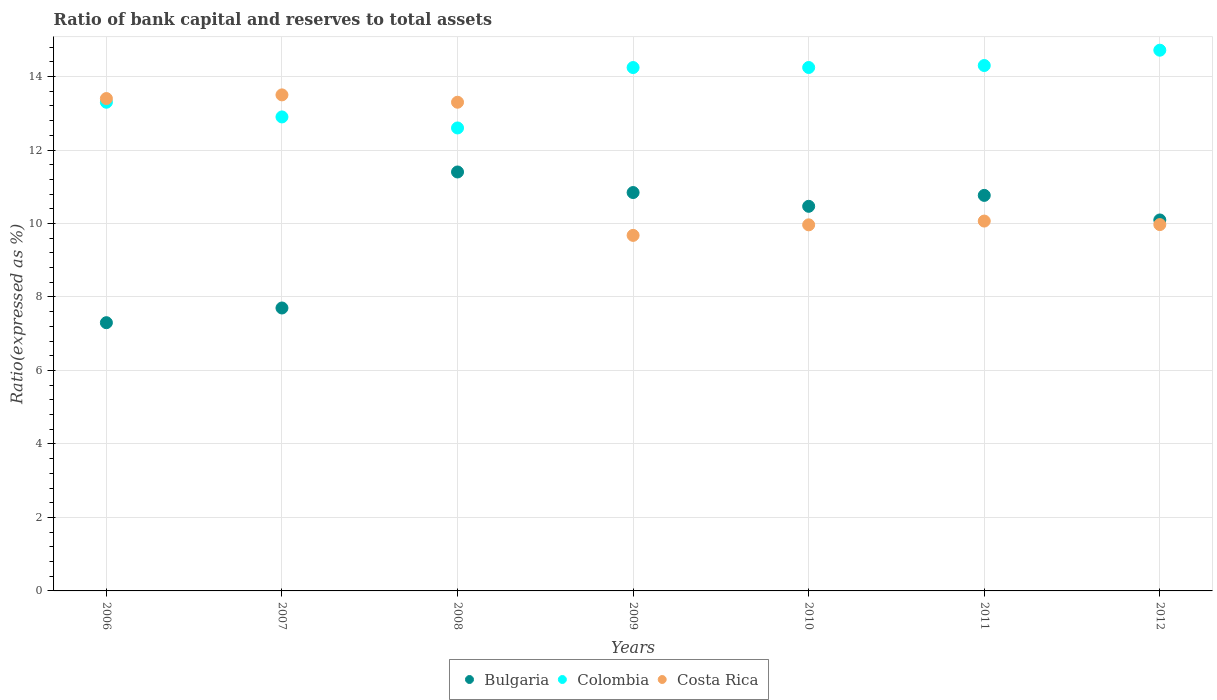How many different coloured dotlines are there?
Ensure brevity in your answer.  3. Is the number of dotlines equal to the number of legend labels?
Give a very brief answer. Yes. What is the ratio of bank capital and reserves to total assets in Bulgaria in 2006?
Your answer should be very brief. 7.3. Across all years, what is the maximum ratio of bank capital and reserves to total assets in Bulgaria?
Provide a succinct answer. 11.4. Across all years, what is the minimum ratio of bank capital and reserves to total assets in Bulgaria?
Provide a succinct answer. 7.3. In which year was the ratio of bank capital and reserves to total assets in Colombia maximum?
Your response must be concise. 2012. What is the total ratio of bank capital and reserves to total assets in Colombia in the graph?
Offer a terse response. 96.31. What is the difference between the ratio of bank capital and reserves to total assets in Colombia in 2006 and that in 2009?
Keep it short and to the point. -0.94. What is the difference between the ratio of bank capital and reserves to total assets in Bulgaria in 2011 and the ratio of bank capital and reserves to total assets in Colombia in 2009?
Offer a very short reply. -3.48. What is the average ratio of bank capital and reserves to total assets in Costa Rica per year?
Offer a terse response. 11.41. In the year 2006, what is the difference between the ratio of bank capital and reserves to total assets in Bulgaria and ratio of bank capital and reserves to total assets in Colombia?
Provide a succinct answer. -6. In how many years, is the ratio of bank capital and reserves to total assets in Bulgaria greater than 14 %?
Keep it short and to the point. 0. What is the ratio of the ratio of bank capital and reserves to total assets in Bulgaria in 2006 to that in 2009?
Provide a succinct answer. 0.67. Is the difference between the ratio of bank capital and reserves to total assets in Bulgaria in 2007 and 2009 greater than the difference between the ratio of bank capital and reserves to total assets in Colombia in 2007 and 2009?
Provide a short and direct response. No. What is the difference between the highest and the second highest ratio of bank capital and reserves to total assets in Bulgaria?
Your answer should be compact. 0.56. What is the difference between the highest and the lowest ratio of bank capital and reserves to total assets in Costa Rica?
Offer a very short reply. 3.82. In how many years, is the ratio of bank capital and reserves to total assets in Bulgaria greater than the average ratio of bank capital and reserves to total assets in Bulgaria taken over all years?
Your answer should be very brief. 5. Is the sum of the ratio of bank capital and reserves to total assets in Costa Rica in 2006 and 2008 greater than the maximum ratio of bank capital and reserves to total assets in Bulgaria across all years?
Give a very brief answer. Yes. Is it the case that in every year, the sum of the ratio of bank capital and reserves to total assets in Costa Rica and ratio of bank capital and reserves to total assets in Colombia  is greater than the ratio of bank capital and reserves to total assets in Bulgaria?
Provide a succinct answer. Yes. Does the ratio of bank capital and reserves to total assets in Bulgaria monotonically increase over the years?
Give a very brief answer. No. Is the ratio of bank capital and reserves to total assets in Colombia strictly greater than the ratio of bank capital and reserves to total assets in Costa Rica over the years?
Offer a very short reply. No. Is the ratio of bank capital and reserves to total assets in Costa Rica strictly less than the ratio of bank capital and reserves to total assets in Colombia over the years?
Keep it short and to the point. No. How many dotlines are there?
Provide a succinct answer. 3. What is the difference between two consecutive major ticks on the Y-axis?
Your answer should be very brief. 2. Are the values on the major ticks of Y-axis written in scientific E-notation?
Your answer should be compact. No. Does the graph contain any zero values?
Offer a terse response. No. Does the graph contain grids?
Provide a succinct answer. Yes. How many legend labels are there?
Give a very brief answer. 3. What is the title of the graph?
Ensure brevity in your answer.  Ratio of bank capital and reserves to total assets. Does "Slovak Republic" appear as one of the legend labels in the graph?
Your answer should be compact. No. What is the label or title of the X-axis?
Keep it short and to the point. Years. What is the label or title of the Y-axis?
Make the answer very short. Ratio(expressed as %). What is the Ratio(expressed as %) in Colombia in 2006?
Your answer should be compact. 13.3. What is the Ratio(expressed as %) in Bulgaria in 2007?
Offer a terse response. 7.7. What is the Ratio(expressed as %) in Colombia in 2007?
Provide a succinct answer. 12.9. What is the Ratio(expressed as %) in Costa Rica in 2007?
Your answer should be very brief. 13.5. What is the Ratio(expressed as %) of Bulgaria in 2008?
Provide a succinct answer. 11.4. What is the Ratio(expressed as %) in Colombia in 2008?
Give a very brief answer. 12.6. What is the Ratio(expressed as %) of Bulgaria in 2009?
Provide a short and direct response. 10.84. What is the Ratio(expressed as %) in Colombia in 2009?
Offer a terse response. 14.24. What is the Ratio(expressed as %) of Costa Rica in 2009?
Ensure brevity in your answer.  9.68. What is the Ratio(expressed as %) in Bulgaria in 2010?
Your response must be concise. 10.47. What is the Ratio(expressed as %) of Colombia in 2010?
Provide a succinct answer. 14.25. What is the Ratio(expressed as %) of Costa Rica in 2010?
Make the answer very short. 9.96. What is the Ratio(expressed as %) of Bulgaria in 2011?
Make the answer very short. 10.76. What is the Ratio(expressed as %) in Colombia in 2011?
Offer a terse response. 14.3. What is the Ratio(expressed as %) in Costa Rica in 2011?
Provide a succinct answer. 10.07. What is the Ratio(expressed as %) of Bulgaria in 2012?
Offer a very short reply. 10.1. What is the Ratio(expressed as %) in Colombia in 2012?
Ensure brevity in your answer.  14.72. What is the Ratio(expressed as %) of Costa Rica in 2012?
Provide a short and direct response. 9.97. Across all years, what is the maximum Ratio(expressed as %) of Bulgaria?
Offer a terse response. 11.4. Across all years, what is the maximum Ratio(expressed as %) of Colombia?
Your answer should be very brief. 14.72. Across all years, what is the minimum Ratio(expressed as %) of Costa Rica?
Keep it short and to the point. 9.68. What is the total Ratio(expressed as %) in Bulgaria in the graph?
Keep it short and to the point. 68.57. What is the total Ratio(expressed as %) in Colombia in the graph?
Make the answer very short. 96.31. What is the total Ratio(expressed as %) of Costa Rica in the graph?
Keep it short and to the point. 79.88. What is the difference between the Ratio(expressed as %) in Bulgaria in 2006 and that in 2007?
Provide a short and direct response. -0.4. What is the difference between the Ratio(expressed as %) in Colombia in 2006 and that in 2007?
Your response must be concise. 0.4. What is the difference between the Ratio(expressed as %) of Bulgaria in 2006 and that in 2008?
Ensure brevity in your answer.  -4.1. What is the difference between the Ratio(expressed as %) in Bulgaria in 2006 and that in 2009?
Your answer should be compact. -3.54. What is the difference between the Ratio(expressed as %) in Colombia in 2006 and that in 2009?
Provide a succinct answer. -0.94. What is the difference between the Ratio(expressed as %) of Costa Rica in 2006 and that in 2009?
Make the answer very short. 3.72. What is the difference between the Ratio(expressed as %) of Bulgaria in 2006 and that in 2010?
Your answer should be very brief. -3.17. What is the difference between the Ratio(expressed as %) in Colombia in 2006 and that in 2010?
Keep it short and to the point. -0.95. What is the difference between the Ratio(expressed as %) of Costa Rica in 2006 and that in 2010?
Your response must be concise. 3.44. What is the difference between the Ratio(expressed as %) of Bulgaria in 2006 and that in 2011?
Make the answer very short. -3.46. What is the difference between the Ratio(expressed as %) of Colombia in 2006 and that in 2011?
Provide a short and direct response. -1. What is the difference between the Ratio(expressed as %) in Costa Rica in 2006 and that in 2011?
Your answer should be very brief. 3.33. What is the difference between the Ratio(expressed as %) in Bulgaria in 2006 and that in 2012?
Keep it short and to the point. -2.8. What is the difference between the Ratio(expressed as %) in Colombia in 2006 and that in 2012?
Your response must be concise. -1.42. What is the difference between the Ratio(expressed as %) of Costa Rica in 2006 and that in 2012?
Offer a very short reply. 3.43. What is the difference between the Ratio(expressed as %) of Bulgaria in 2007 and that in 2008?
Give a very brief answer. -3.7. What is the difference between the Ratio(expressed as %) in Bulgaria in 2007 and that in 2009?
Your answer should be very brief. -3.14. What is the difference between the Ratio(expressed as %) of Colombia in 2007 and that in 2009?
Ensure brevity in your answer.  -1.34. What is the difference between the Ratio(expressed as %) of Costa Rica in 2007 and that in 2009?
Your answer should be very brief. 3.82. What is the difference between the Ratio(expressed as %) in Bulgaria in 2007 and that in 2010?
Ensure brevity in your answer.  -2.77. What is the difference between the Ratio(expressed as %) in Colombia in 2007 and that in 2010?
Give a very brief answer. -1.35. What is the difference between the Ratio(expressed as %) in Costa Rica in 2007 and that in 2010?
Provide a succinct answer. 3.54. What is the difference between the Ratio(expressed as %) of Bulgaria in 2007 and that in 2011?
Keep it short and to the point. -3.06. What is the difference between the Ratio(expressed as %) of Colombia in 2007 and that in 2011?
Offer a terse response. -1.4. What is the difference between the Ratio(expressed as %) in Costa Rica in 2007 and that in 2011?
Keep it short and to the point. 3.43. What is the difference between the Ratio(expressed as %) in Bulgaria in 2007 and that in 2012?
Give a very brief answer. -2.4. What is the difference between the Ratio(expressed as %) in Colombia in 2007 and that in 2012?
Your answer should be very brief. -1.82. What is the difference between the Ratio(expressed as %) of Costa Rica in 2007 and that in 2012?
Provide a succinct answer. 3.53. What is the difference between the Ratio(expressed as %) of Bulgaria in 2008 and that in 2009?
Your answer should be compact. 0.56. What is the difference between the Ratio(expressed as %) in Colombia in 2008 and that in 2009?
Offer a very short reply. -1.64. What is the difference between the Ratio(expressed as %) of Costa Rica in 2008 and that in 2009?
Keep it short and to the point. 3.62. What is the difference between the Ratio(expressed as %) in Bulgaria in 2008 and that in 2010?
Ensure brevity in your answer.  0.93. What is the difference between the Ratio(expressed as %) in Colombia in 2008 and that in 2010?
Ensure brevity in your answer.  -1.65. What is the difference between the Ratio(expressed as %) of Costa Rica in 2008 and that in 2010?
Provide a short and direct response. 3.34. What is the difference between the Ratio(expressed as %) in Bulgaria in 2008 and that in 2011?
Offer a terse response. 0.64. What is the difference between the Ratio(expressed as %) of Colombia in 2008 and that in 2011?
Keep it short and to the point. -1.7. What is the difference between the Ratio(expressed as %) of Costa Rica in 2008 and that in 2011?
Offer a terse response. 3.23. What is the difference between the Ratio(expressed as %) of Bulgaria in 2008 and that in 2012?
Give a very brief answer. 1.31. What is the difference between the Ratio(expressed as %) of Colombia in 2008 and that in 2012?
Your answer should be very brief. -2.12. What is the difference between the Ratio(expressed as %) in Costa Rica in 2008 and that in 2012?
Your response must be concise. 3.33. What is the difference between the Ratio(expressed as %) of Bulgaria in 2009 and that in 2010?
Make the answer very short. 0.37. What is the difference between the Ratio(expressed as %) of Colombia in 2009 and that in 2010?
Give a very brief answer. -0. What is the difference between the Ratio(expressed as %) of Costa Rica in 2009 and that in 2010?
Make the answer very short. -0.29. What is the difference between the Ratio(expressed as %) in Bulgaria in 2009 and that in 2011?
Offer a terse response. 0.08. What is the difference between the Ratio(expressed as %) in Colombia in 2009 and that in 2011?
Provide a succinct answer. -0.06. What is the difference between the Ratio(expressed as %) in Costa Rica in 2009 and that in 2011?
Ensure brevity in your answer.  -0.39. What is the difference between the Ratio(expressed as %) in Bulgaria in 2009 and that in 2012?
Ensure brevity in your answer.  0.75. What is the difference between the Ratio(expressed as %) of Colombia in 2009 and that in 2012?
Your answer should be compact. -0.47. What is the difference between the Ratio(expressed as %) in Costa Rica in 2009 and that in 2012?
Ensure brevity in your answer.  -0.29. What is the difference between the Ratio(expressed as %) in Bulgaria in 2010 and that in 2011?
Give a very brief answer. -0.3. What is the difference between the Ratio(expressed as %) of Colombia in 2010 and that in 2011?
Ensure brevity in your answer.  -0.05. What is the difference between the Ratio(expressed as %) of Costa Rica in 2010 and that in 2011?
Make the answer very short. -0.1. What is the difference between the Ratio(expressed as %) in Bulgaria in 2010 and that in 2012?
Give a very brief answer. 0.37. What is the difference between the Ratio(expressed as %) in Colombia in 2010 and that in 2012?
Your response must be concise. -0.47. What is the difference between the Ratio(expressed as %) of Costa Rica in 2010 and that in 2012?
Your answer should be compact. -0.01. What is the difference between the Ratio(expressed as %) in Bulgaria in 2011 and that in 2012?
Your response must be concise. 0.67. What is the difference between the Ratio(expressed as %) of Colombia in 2011 and that in 2012?
Offer a very short reply. -0.42. What is the difference between the Ratio(expressed as %) in Costa Rica in 2011 and that in 2012?
Your answer should be very brief. 0.1. What is the difference between the Ratio(expressed as %) in Bulgaria in 2006 and the Ratio(expressed as %) in Costa Rica in 2007?
Keep it short and to the point. -6.2. What is the difference between the Ratio(expressed as %) in Bulgaria in 2006 and the Ratio(expressed as %) in Colombia in 2008?
Ensure brevity in your answer.  -5.3. What is the difference between the Ratio(expressed as %) of Bulgaria in 2006 and the Ratio(expressed as %) of Costa Rica in 2008?
Ensure brevity in your answer.  -6. What is the difference between the Ratio(expressed as %) in Bulgaria in 2006 and the Ratio(expressed as %) in Colombia in 2009?
Your answer should be very brief. -6.94. What is the difference between the Ratio(expressed as %) of Bulgaria in 2006 and the Ratio(expressed as %) of Costa Rica in 2009?
Offer a very short reply. -2.38. What is the difference between the Ratio(expressed as %) of Colombia in 2006 and the Ratio(expressed as %) of Costa Rica in 2009?
Keep it short and to the point. 3.62. What is the difference between the Ratio(expressed as %) of Bulgaria in 2006 and the Ratio(expressed as %) of Colombia in 2010?
Your answer should be very brief. -6.95. What is the difference between the Ratio(expressed as %) of Bulgaria in 2006 and the Ratio(expressed as %) of Costa Rica in 2010?
Provide a short and direct response. -2.66. What is the difference between the Ratio(expressed as %) in Colombia in 2006 and the Ratio(expressed as %) in Costa Rica in 2010?
Keep it short and to the point. 3.34. What is the difference between the Ratio(expressed as %) in Bulgaria in 2006 and the Ratio(expressed as %) in Colombia in 2011?
Your answer should be very brief. -7. What is the difference between the Ratio(expressed as %) of Bulgaria in 2006 and the Ratio(expressed as %) of Costa Rica in 2011?
Give a very brief answer. -2.77. What is the difference between the Ratio(expressed as %) of Colombia in 2006 and the Ratio(expressed as %) of Costa Rica in 2011?
Offer a very short reply. 3.23. What is the difference between the Ratio(expressed as %) of Bulgaria in 2006 and the Ratio(expressed as %) of Colombia in 2012?
Provide a short and direct response. -7.42. What is the difference between the Ratio(expressed as %) of Bulgaria in 2006 and the Ratio(expressed as %) of Costa Rica in 2012?
Ensure brevity in your answer.  -2.67. What is the difference between the Ratio(expressed as %) in Colombia in 2006 and the Ratio(expressed as %) in Costa Rica in 2012?
Offer a very short reply. 3.33. What is the difference between the Ratio(expressed as %) in Bulgaria in 2007 and the Ratio(expressed as %) in Colombia in 2008?
Offer a terse response. -4.9. What is the difference between the Ratio(expressed as %) in Bulgaria in 2007 and the Ratio(expressed as %) in Costa Rica in 2008?
Your answer should be compact. -5.6. What is the difference between the Ratio(expressed as %) in Colombia in 2007 and the Ratio(expressed as %) in Costa Rica in 2008?
Make the answer very short. -0.4. What is the difference between the Ratio(expressed as %) in Bulgaria in 2007 and the Ratio(expressed as %) in Colombia in 2009?
Your answer should be very brief. -6.54. What is the difference between the Ratio(expressed as %) of Bulgaria in 2007 and the Ratio(expressed as %) of Costa Rica in 2009?
Your response must be concise. -1.98. What is the difference between the Ratio(expressed as %) in Colombia in 2007 and the Ratio(expressed as %) in Costa Rica in 2009?
Keep it short and to the point. 3.22. What is the difference between the Ratio(expressed as %) of Bulgaria in 2007 and the Ratio(expressed as %) of Colombia in 2010?
Provide a succinct answer. -6.55. What is the difference between the Ratio(expressed as %) of Bulgaria in 2007 and the Ratio(expressed as %) of Costa Rica in 2010?
Your answer should be very brief. -2.26. What is the difference between the Ratio(expressed as %) in Colombia in 2007 and the Ratio(expressed as %) in Costa Rica in 2010?
Your response must be concise. 2.94. What is the difference between the Ratio(expressed as %) of Bulgaria in 2007 and the Ratio(expressed as %) of Colombia in 2011?
Your response must be concise. -6.6. What is the difference between the Ratio(expressed as %) in Bulgaria in 2007 and the Ratio(expressed as %) in Costa Rica in 2011?
Offer a very short reply. -2.37. What is the difference between the Ratio(expressed as %) in Colombia in 2007 and the Ratio(expressed as %) in Costa Rica in 2011?
Your answer should be compact. 2.83. What is the difference between the Ratio(expressed as %) in Bulgaria in 2007 and the Ratio(expressed as %) in Colombia in 2012?
Make the answer very short. -7.02. What is the difference between the Ratio(expressed as %) in Bulgaria in 2007 and the Ratio(expressed as %) in Costa Rica in 2012?
Offer a terse response. -2.27. What is the difference between the Ratio(expressed as %) of Colombia in 2007 and the Ratio(expressed as %) of Costa Rica in 2012?
Offer a terse response. 2.93. What is the difference between the Ratio(expressed as %) of Bulgaria in 2008 and the Ratio(expressed as %) of Colombia in 2009?
Your answer should be compact. -2.84. What is the difference between the Ratio(expressed as %) in Bulgaria in 2008 and the Ratio(expressed as %) in Costa Rica in 2009?
Your answer should be compact. 1.73. What is the difference between the Ratio(expressed as %) in Colombia in 2008 and the Ratio(expressed as %) in Costa Rica in 2009?
Your response must be concise. 2.92. What is the difference between the Ratio(expressed as %) in Bulgaria in 2008 and the Ratio(expressed as %) in Colombia in 2010?
Offer a very short reply. -2.84. What is the difference between the Ratio(expressed as %) in Bulgaria in 2008 and the Ratio(expressed as %) in Costa Rica in 2010?
Make the answer very short. 1.44. What is the difference between the Ratio(expressed as %) of Colombia in 2008 and the Ratio(expressed as %) of Costa Rica in 2010?
Give a very brief answer. 2.64. What is the difference between the Ratio(expressed as %) in Bulgaria in 2008 and the Ratio(expressed as %) in Colombia in 2011?
Make the answer very short. -2.9. What is the difference between the Ratio(expressed as %) of Bulgaria in 2008 and the Ratio(expressed as %) of Costa Rica in 2011?
Provide a succinct answer. 1.34. What is the difference between the Ratio(expressed as %) of Colombia in 2008 and the Ratio(expressed as %) of Costa Rica in 2011?
Your answer should be very brief. 2.53. What is the difference between the Ratio(expressed as %) of Bulgaria in 2008 and the Ratio(expressed as %) of Colombia in 2012?
Offer a terse response. -3.31. What is the difference between the Ratio(expressed as %) of Bulgaria in 2008 and the Ratio(expressed as %) of Costa Rica in 2012?
Make the answer very short. 1.43. What is the difference between the Ratio(expressed as %) of Colombia in 2008 and the Ratio(expressed as %) of Costa Rica in 2012?
Offer a very short reply. 2.63. What is the difference between the Ratio(expressed as %) in Bulgaria in 2009 and the Ratio(expressed as %) in Colombia in 2010?
Offer a terse response. -3.4. What is the difference between the Ratio(expressed as %) in Bulgaria in 2009 and the Ratio(expressed as %) in Costa Rica in 2010?
Provide a succinct answer. 0.88. What is the difference between the Ratio(expressed as %) of Colombia in 2009 and the Ratio(expressed as %) of Costa Rica in 2010?
Offer a terse response. 4.28. What is the difference between the Ratio(expressed as %) of Bulgaria in 2009 and the Ratio(expressed as %) of Colombia in 2011?
Make the answer very short. -3.46. What is the difference between the Ratio(expressed as %) of Bulgaria in 2009 and the Ratio(expressed as %) of Costa Rica in 2011?
Offer a terse response. 0.78. What is the difference between the Ratio(expressed as %) in Colombia in 2009 and the Ratio(expressed as %) in Costa Rica in 2011?
Offer a very short reply. 4.18. What is the difference between the Ratio(expressed as %) of Bulgaria in 2009 and the Ratio(expressed as %) of Colombia in 2012?
Your answer should be very brief. -3.87. What is the difference between the Ratio(expressed as %) in Bulgaria in 2009 and the Ratio(expressed as %) in Costa Rica in 2012?
Provide a succinct answer. 0.87. What is the difference between the Ratio(expressed as %) of Colombia in 2009 and the Ratio(expressed as %) of Costa Rica in 2012?
Offer a terse response. 4.27. What is the difference between the Ratio(expressed as %) in Bulgaria in 2010 and the Ratio(expressed as %) in Colombia in 2011?
Your answer should be very brief. -3.83. What is the difference between the Ratio(expressed as %) of Bulgaria in 2010 and the Ratio(expressed as %) of Costa Rica in 2011?
Your answer should be compact. 0.4. What is the difference between the Ratio(expressed as %) in Colombia in 2010 and the Ratio(expressed as %) in Costa Rica in 2011?
Your answer should be compact. 4.18. What is the difference between the Ratio(expressed as %) in Bulgaria in 2010 and the Ratio(expressed as %) in Colombia in 2012?
Your response must be concise. -4.25. What is the difference between the Ratio(expressed as %) of Bulgaria in 2010 and the Ratio(expressed as %) of Costa Rica in 2012?
Ensure brevity in your answer.  0.5. What is the difference between the Ratio(expressed as %) in Colombia in 2010 and the Ratio(expressed as %) in Costa Rica in 2012?
Your answer should be compact. 4.28. What is the difference between the Ratio(expressed as %) of Bulgaria in 2011 and the Ratio(expressed as %) of Colombia in 2012?
Ensure brevity in your answer.  -3.95. What is the difference between the Ratio(expressed as %) in Bulgaria in 2011 and the Ratio(expressed as %) in Costa Rica in 2012?
Your answer should be very brief. 0.79. What is the difference between the Ratio(expressed as %) of Colombia in 2011 and the Ratio(expressed as %) of Costa Rica in 2012?
Your answer should be very brief. 4.33. What is the average Ratio(expressed as %) of Bulgaria per year?
Offer a terse response. 9.8. What is the average Ratio(expressed as %) of Colombia per year?
Offer a very short reply. 13.76. What is the average Ratio(expressed as %) of Costa Rica per year?
Keep it short and to the point. 11.41. In the year 2006, what is the difference between the Ratio(expressed as %) of Bulgaria and Ratio(expressed as %) of Colombia?
Make the answer very short. -6. In the year 2007, what is the difference between the Ratio(expressed as %) in Colombia and Ratio(expressed as %) in Costa Rica?
Keep it short and to the point. -0.6. In the year 2008, what is the difference between the Ratio(expressed as %) of Bulgaria and Ratio(expressed as %) of Colombia?
Your answer should be very brief. -1.2. In the year 2008, what is the difference between the Ratio(expressed as %) of Bulgaria and Ratio(expressed as %) of Costa Rica?
Offer a terse response. -1.9. In the year 2008, what is the difference between the Ratio(expressed as %) in Colombia and Ratio(expressed as %) in Costa Rica?
Provide a succinct answer. -0.7. In the year 2009, what is the difference between the Ratio(expressed as %) in Bulgaria and Ratio(expressed as %) in Colombia?
Your answer should be very brief. -3.4. In the year 2009, what is the difference between the Ratio(expressed as %) in Bulgaria and Ratio(expressed as %) in Costa Rica?
Ensure brevity in your answer.  1.17. In the year 2009, what is the difference between the Ratio(expressed as %) in Colombia and Ratio(expressed as %) in Costa Rica?
Keep it short and to the point. 4.57. In the year 2010, what is the difference between the Ratio(expressed as %) of Bulgaria and Ratio(expressed as %) of Colombia?
Your answer should be very brief. -3.78. In the year 2010, what is the difference between the Ratio(expressed as %) of Bulgaria and Ratio(expressed as %) of Costa Rica?
Your answer should be compact. 0.5. In the year 2010, what is the difference between the Ratio(expressed as %) of Colombia and Ratio(expressed as %) of Costa Rica?
Offer a very short reply. 4.28. In the year 2011, what is the difference between the Ratio(expressed as %) in Bulgaria and Ratio(expressed as %) in Colombia?
Provide a short and direct response. -3.53. In the year 2011, what is the difference between the Ratio(expressed as %) in Bulgaria and Ratio(expressed as %) in Costa Rica?
Keep it short and to the point. 0.7. In the year 2011, what is the difference between the Ratio(expressed as %) of Colombia and Ratio(expressed as %) of Costa Rica?
Your answer should be very brief. 4.23. In the year 2012, what is the difference between the Ratio(expressed as %) in Bulgaria and Ratio(expressed as %) in Colombia?
Your answer should be compact. -4.62. In the year 2012, what is the difference between the Ratio(expressed as %) of Bulgaria and Ratio(expressed as %) of Costa Rica?
Keep it short and to the point. 0.13. In the year 2012, what is the difference between the Ratio(expressed as %) in Colombia and Ratio(expressed as %) in Costa Rica?
Make the answer very short. 4.75. What is the ratio of the Ratio(expressed as %) in Bulgaria in 2006 to that in 2007?
Your answer should be very brief. 0.95. What is the ratio of the Ratio(expressed as %) in Colombia in 2006 to that in 2007?
Ensure brevity in your answer.  1.03. What is the ratio of the Ratio(expressed as %) of Costa Rica in 2006 to that in 2007?
Your answer should be very brief. 0.99. What is the ratio of the Ratio(expressed as %) in Bulgaria in 2006 to that in 2008?
Provide a succinct answer. 0.64. What is the ratio of the Ratio(expressed as %) in Colombia in 2006 to that in 2008?
Give a very brief answer. 1.06. What is the ratio of the Ratio(expressed as %) of Costa Rica in 2006 to that in 2008?
Provide a short and direct response. 1.01. What is the ratio of the Ratio(expressed as %) in Bulgaria in 2006 to that in 2009?
Give a very brief answer. 0.67. What is the ratio of the Ratio(expressed as %) of Colombia in 2006 to that in 2009?
Ensure brevity in your answer.  0.93. What is the ratio of the Ratio(expressed as %) in Costa Rica in 2006 to that in 2009?
Ensure brevity in your answer.  1.38. What is the ratio of the Ratio(expressed as %) in Bulgaria in 2006 to that in 2010?
Provide a short and direct response. 0.7. What is the ratio of the Ratio(expressed as %) in Colombia in 2006 to that in 2010?
Ensure brevity in your answer.  0.93. What is the ratio of the Ratio(expressed as %) in Costa Rica in 2006 to that in 2010?
Provide a short and direct response. 1.34. What is the ratio of the Ratio(expressed as %) in Bulgaria in 2006 to that in 2011?
Offer a very short reply. 0.68. What is the ratio of the Ratio(expressed as %) in Colombia in 2006 to that in 2011?
Your response must be concise. 0.93. What is the ratio of the Ratio(expressed as %) of Costa Rica in 2006 to that in 2011?
Ensure brevity in your answer.  1.33. What is the ratio of the Ratio(expressed as %) in Bulgaria in 2006 to that in 2012?
Make the answer very short. 0.72. What is the ratio of the Ratio(expressed as %) in Colombia in 2006 to that in 2012?
Keep it short and to the point. 0.9. What is the ratio of the Ratio(expressed as %) in Costa Rica in 2006 to that in 2012?
Ensure brevity in your answer.  1.34. What is the ratio of the Ratio(expressed as %) of Bulgaria in 2007 to that in 2008?
Your response must be concise. 0.68. What is the ratio of the Ratio(expressed as %) of Colombia in 2007 to that in 2008?
Your answer should be very brief. 1.02. What is the ratio of the Ratio(expressed as %) of Costa Rica in 2007 to that in 2008?
Keep it short and to the point. 1.01. What is the ratio of the Ratio(expressed as %) of Bulgaria in 2007 to that in 2009?
Your answer should be very brief. 0.71. What is the ratio of the Ratio(expressed as %) of Colombia in 2007 to that in 2009?
Your response must be concise. 0.91. What is the ratio of the Ratio(expressed as %) of Costa Rica in 2007 to that in 2009?
Offer a terse response. 1.4. What is the ratio of the Ratio(expressed as %) of Bulgaria in 2007 to that in 2010?
Offer a very short reply. 0.74. What is the ratio of the Ratio(expressed as %) of Colombia in 2007 to that in 2010?
Your answer should be very brief. 0.91. What is the ratio of the Ratio(expressed as %) in Costa Rica in 2007 to that in 2010?
Offer a very short reply. 1.35. What is the ratio of the Ratio(expressed as %) of Bulgaria in 2007 to that in 2011?
Ensure brevity in your answer.  0.72. What is the ratio of the Ratio(expressed as %) of Colombia in 2007 to that in 2011?
Your response must be concise. 0.9. What is the ratio of the Ratio(expressed as %) of Costa Rica in 2007 to that in 2011?
Your answer should be very brief. 1.34. What is the ratio of the Ratio(expressed as %) in Bulgaria in 2007 to that in 2012?
Offer a terse response. 0.76. What is the ratio of the Ratio(expressed as %) in Colombia in 2007 to that in 2012?
Keep it short and to the point. 0.88. What is the ratio of the Ratio(expressed as %) of Costa Rica in 2007 to that in 2012?
Give a very brief answer. 1.35. What is the ratio of the Ratio(expressed as %) in Bulgaria in 2008 to that in 2009?
Your response must be concise. 1.05. What is the ratio of the Ratio(expressed as %) of Colombia in 2008 to that in 2009?
Keep it short and to the point. 0.88. What is the ratio of the Ratio(expressed as %) of Costa Rica in 2008 to that in 2009?
Offer a terse response. 1.37. What is the ratio of the Ratio(expressed as %) in Bulgaria in 2008 to that in 2010?
Give a very brief answer. 1.09. What is the ratio of the Ratio(expressed as %) in Colombia in 2008 to that in 2010?
Offer a very short reply. 0.88. What is the ratio of the Ratio(expressed as %) in Costa Rica in 2008 to that in 2010?
Make the answer very short. 1.33. What is the ratio of the Ratio(expressed as %) of Bulgaria in 2008 to that in 2011?
Make the answer very short. 1.06. What is the ratio of the Ratio(expressed as %) of Colombia in 2008 to that in 2011?
Give a very brief answer. 0.88. What is the ratio of the Ratio(expressed as %) in Costa Rica in 2008 to that in 2011?
Keep it short and to the point. 1.32. What is the ratio of the Ratio(expressed as %) of Bulgaria in 2008 to that in 2012?
Offer a terse response. 1.13. What is the ratio of the Ratio(expressed as %) in Colombia in 2008 to that in 2012?
Give a very brief answer. 0.86. What is the ratio of the Ratio(expressed as %) of Costa Rica in 2008 to that in 2012?
Offer a very short reply. 1.33. What is the ratio of the Ratio(expressed as %) of Bulgaria in 2009 to that in 2010?
Make the answer very short. 1.04. What is the ratio of the Ratio(expressed as %) in Costa Rica in 2009 to that in 2010?
Give a very brief answer. 0.97. What is the ratio of the Ratio(expressed as %) in Colombia in 2009 to that in 2011?
Provide a succinct answer. 1. What is the ratio of the Ratio(expressed as %) of Costa Rica in 2009 to that in 2011?
Your answer should be very brief. 0.96. What is the ratio of the Ratio(expressed as %) of Bulgaria in 2009 to that in 2012?
Your answer should be very brief. 1.07. What is the ratio of the Ratio(expressed as %) in Colombia in 2009 to that in 2012?
Your answer should be very brief. 0.97. What is the ratio of the Ratio(expressed as %) in Costa Rica in 2009 to that in 2012?
Ensure brevity in your answer.  0.97. What is the ratio of the Ratio(expressed as %) of Bulgaria in 2010 to that in 2011?
Provide a short and direct response. 0.97. What is the ratio of the Ratio(expressed as %) of Colombia in 2010 to that in 2011?
Your answer should be very brief. 1. What is the ratio of the Ratio(expressed as %) in Bulgaria in 2010 to that in 2012?
Offer a terse response. 1.04. What is the ratio of the Ratio(expressed as %) in Colombia in 2010 to that in 2012?
Make the answer very short. 0.97. What is the ratio of the Ratio(expressed as %) of Costa Rica in 2010 to that in 2012?
Keep it short and to the point. 1. What is the ratio of the Ratio(expressed as %) of Bulgaria in 2011 to that in 2012?
Provide a short and direct response. 1.07. What is the ratio of the Ratio(expressed as %) of Colombia in 2011 to that in 2012?
Your answer should be very brief. 0.97. What is the ratio of the Ratio(expressed as %) in Costa Rica in 2011 to that in 2012?
Make the answer very short. 1.01. What is the difference between the highest and the second highest Ratio(expressed as %) in Bulgaria?
Ensure brevity in your answer.  0.56. What is the difference between the highest and the second highest Ratio(expressed as %) in Colombia?
Provide a succinct answer. 0.42. What is the difference between the highest and the second highest Ratio(expressed as %) of Costa Rica?
Give a very brief answer. 0.1. What is the difference between the highest and the lowest Ratio(expressed as %) in Bulgaria?
Give a very brief answer. 4.1. What is the difference between the highest and the lowest Ratio(expressed as %) of Colombia?
Your answer should be very brief. 2.12. What is the difference between the highest and the lowest Ratio(expressed as %) in Costa Rica?
Give a very brief answer. 3.82. 